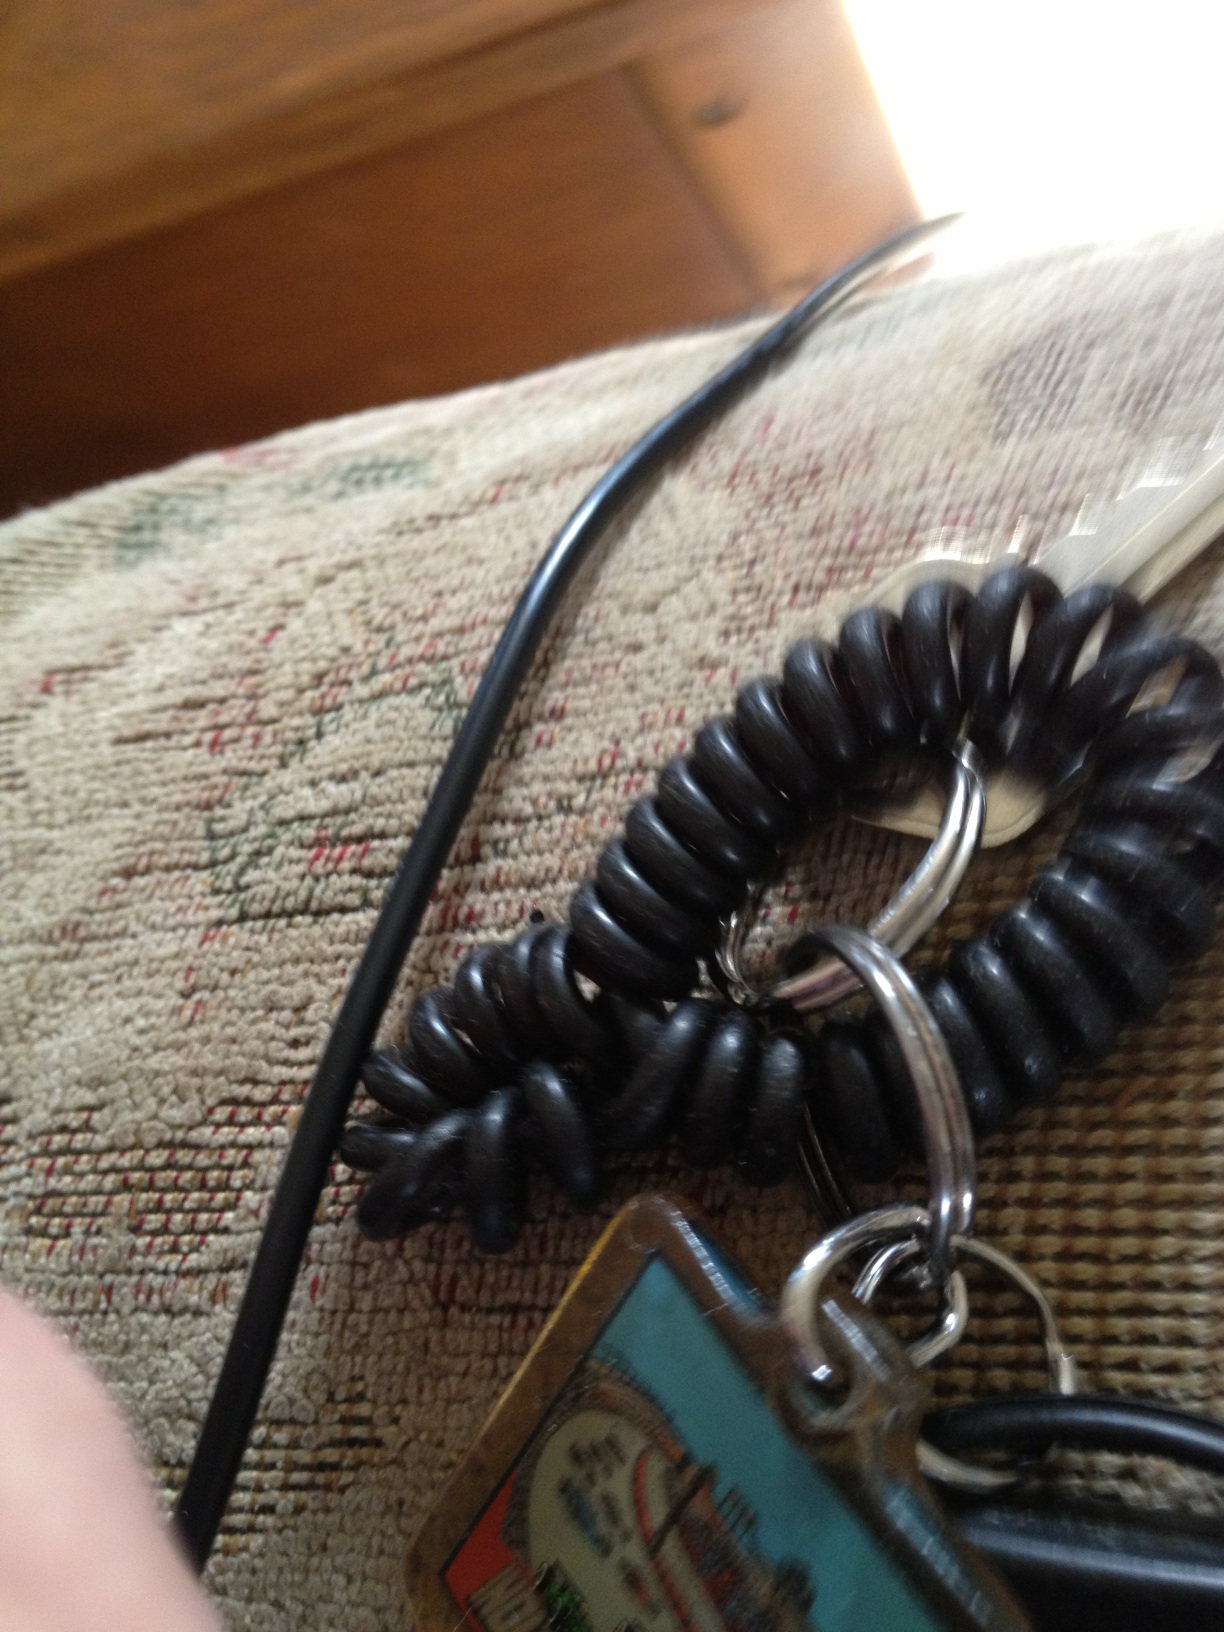Where do you think this keychain might come from? The keychain may come from a souvenir shop as it appears to have a colorful tag that is often associated with tourist locations or events. These tags typically display landmarks, logos, or artwork representing a specific place. Can you speculate on the story behind the design on the tag? Based on the image on the tag, it might be showing a famous landmark or an iconic structure. It could represent a memorable trip to an amusement park, museum, or a notable city skyline. The design likely holds sentimental value, reminding the owner of a specific travel experience or special event they attended. 